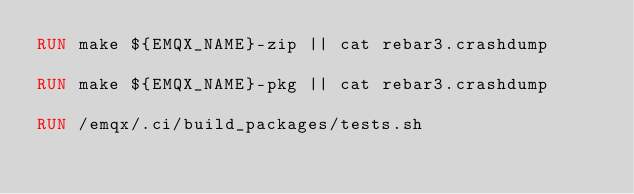<code> <loc_0><loc_0><loc_500><loc_500><_Dockerfile_>RUN make ${EMQX_NAME}-zip || cat rebar3.crashdump

RUN make ${EMQX_NAME}-pkg || cat rebar3.crashdump

RUN /emqx/.ci/build_packages/tests.sh
</code> 